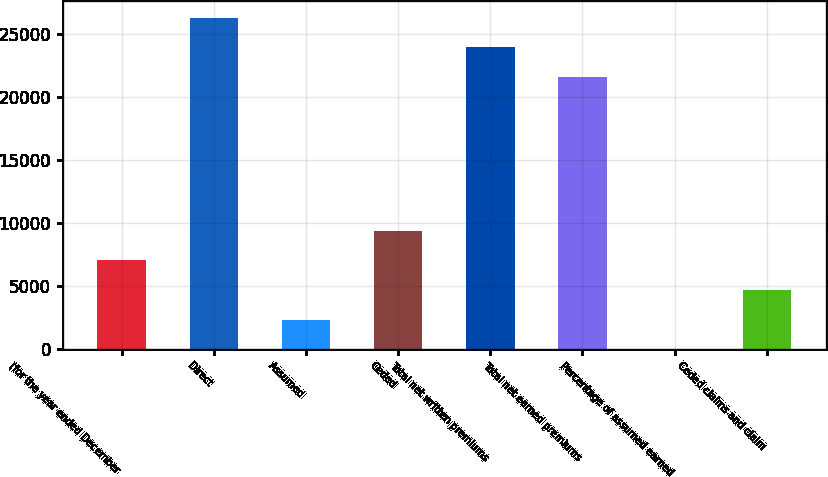<chart> <loc_0><loc_0><loc_500><loc_500><bar_chart><fcel>(for the year ended December<fcel>Direct<fcel>Assumed<fcel>Ceded<fcel>Total net written premiums<fcel>Total net earned premiums<fcel>Percentage of assumed earned<fcel>Ceded claims and claim<nl><fcel>7041.96<fcel>26272.4<fcel>2348.52<fcel>9388.68<fcel>23925.7<fcel>21579<fcel>1.8<fcel>4695.24<nl></chart> 